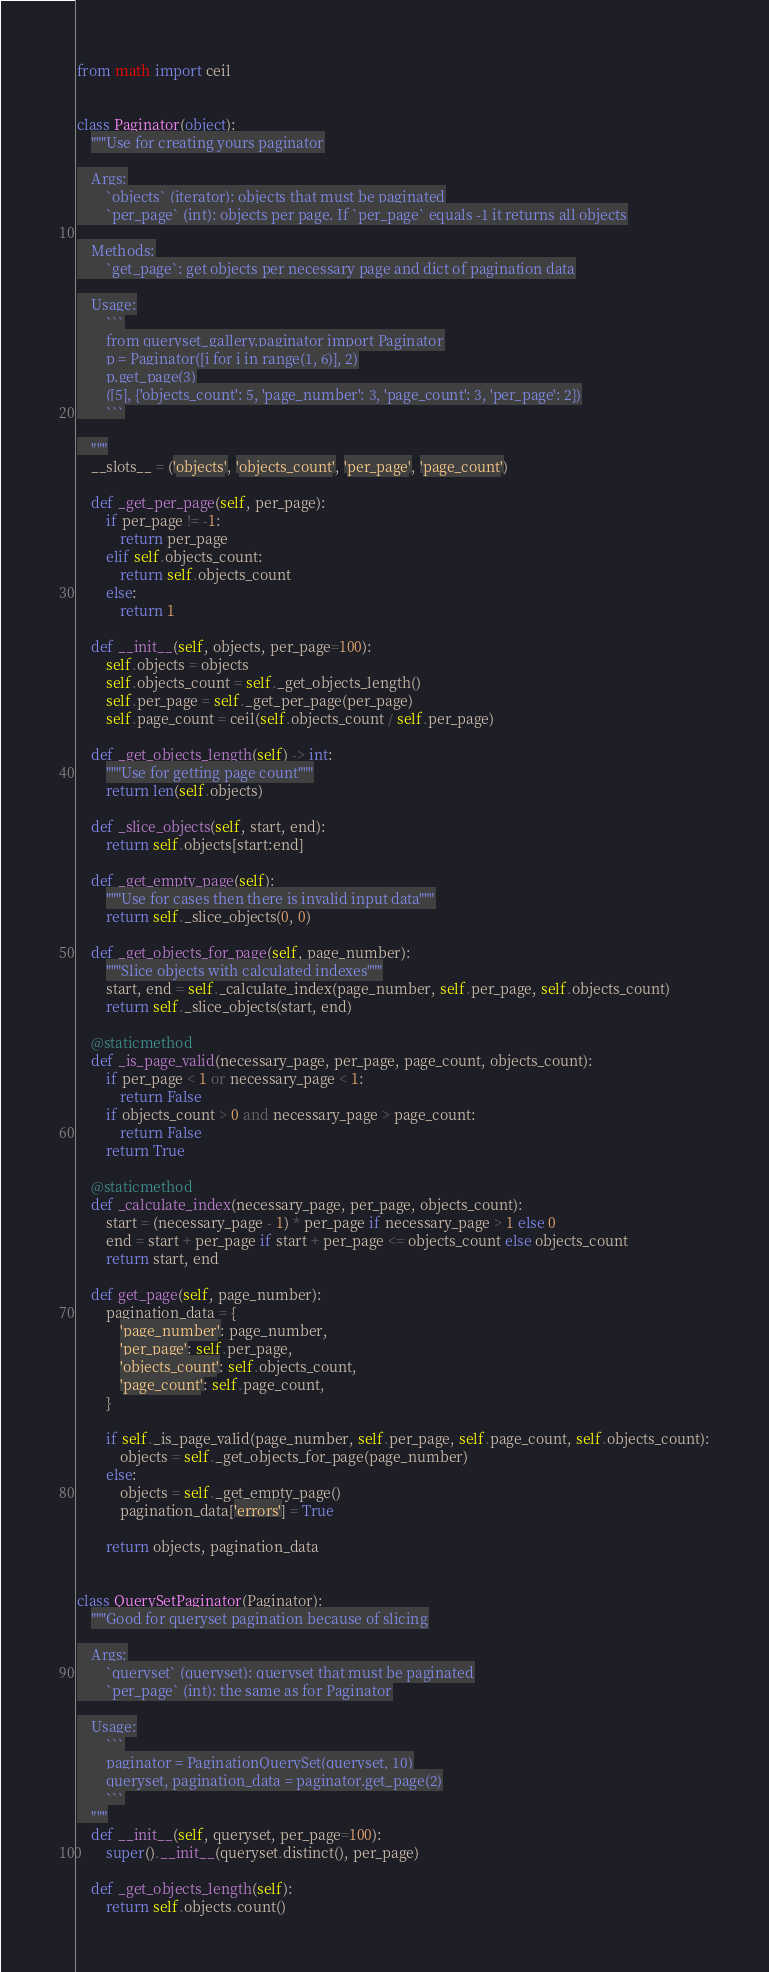<code> <loc_0><loc_0><loc_500><loc_500><_Python_>from math import ceil


class Paginator(object):
    """Use for creating yours paginator

    Args:
        `objects` (iterator): objects that must be paginated
        `per_page` (int): objects per page. If `per_page` equals -1 it returns all objects

    Methods:
        `get_page`: get objects per necessary page and dict of pagination data

    Usage:
        ```
        from queryset_gallery.paginator import Paginator
        p = Paginator([i for i in range(1, 6)], 2)
        p.get_page(3)
        ([5], {'objects_count': 5, 'page_number': 3, 'page_count': 3, 'per_page': 2})
        ```

    """
    __slots__ = ('objects', 'objects_count', 'per_page', 'page_count')

    def _get_per_page(self, per_page):
        if per_page != -1:
            return per_page
        elif self.objects_count:
            return self.objects_count
        else:
            return 1

    def __init__(self, objects, per_page=100):
        self.objects = objects
        self.objects_count = self._get_objects_length()
        self.per_page = self._get_per_page(per_page)
        self.page_count = ceil(self.objects_count / self.per_page)

    def _get_objects_length(self) -> int:
        """Use for getting page count"""
        return len(self.objects)

    def _slice_objects(self, start, end):
        return self.objects[start:end]

    def _get_empty_page(self):
        """Use for cases then there is invalid input data"""
        return self._slice_objects(0, 0)

    def _get_objects_for_page(self, page_number):
        """Slice objects with calculated indexes"""
        start, end = self._calculate_index(page_number, self.per_page, self.objects_count)
        return self._slice_objects(start, end)

    @staticmethod
    def _is_page_valid(necessary_page, per_page, page_count, objects_count):
        if per_page < 1 or necessary_page < 1:
            return False
        if objects_count > 0 and necessary_page > page_count:
            return False
        return True

    @staticmethod
    def _calculate_index(necessary_page, per_page, objects_count):
        start = (necessary_page - 1) * per_page if necessary_page > 1 else 0
        end = start + per_page if start + per_page <= objects_count else objects_count
        return start, end

    def get_page(self, page_number):
        pagination_data = {
            'page_number': page_number,
            'per_page': self.per_page,
            'objects_count': self.objects_count,
            'page_count': self.page_count,
        }

        if self._is_page_valid(page_number, self.per_page, self.page_count, self.objects_count):
            objects = self._get_objects_for_page(page_number)
        else:
            objects = self._get_empty_page()
            pagination_data['errors'] = True

        return objects, pagination_data


class QuerySetPaginator(Paginator):
    """Good for queryset pagination because of slicing

    Args:
        `queryset` (queryset): queryset that must be paginated
        `per_page` (int): the same as for Paginator

    Usage:
        ```
        paginator = PaginationQuerySet(queryset, 10)
        queryset, pagination_data = paginator.get_page(2)
        ```
    """
    def __init__(self, queryset, per_page=100):
        super().__init__(queryset.distinct(), per_page)

    def _get_objects_length(self):
        return self.objects.count()
</code> 